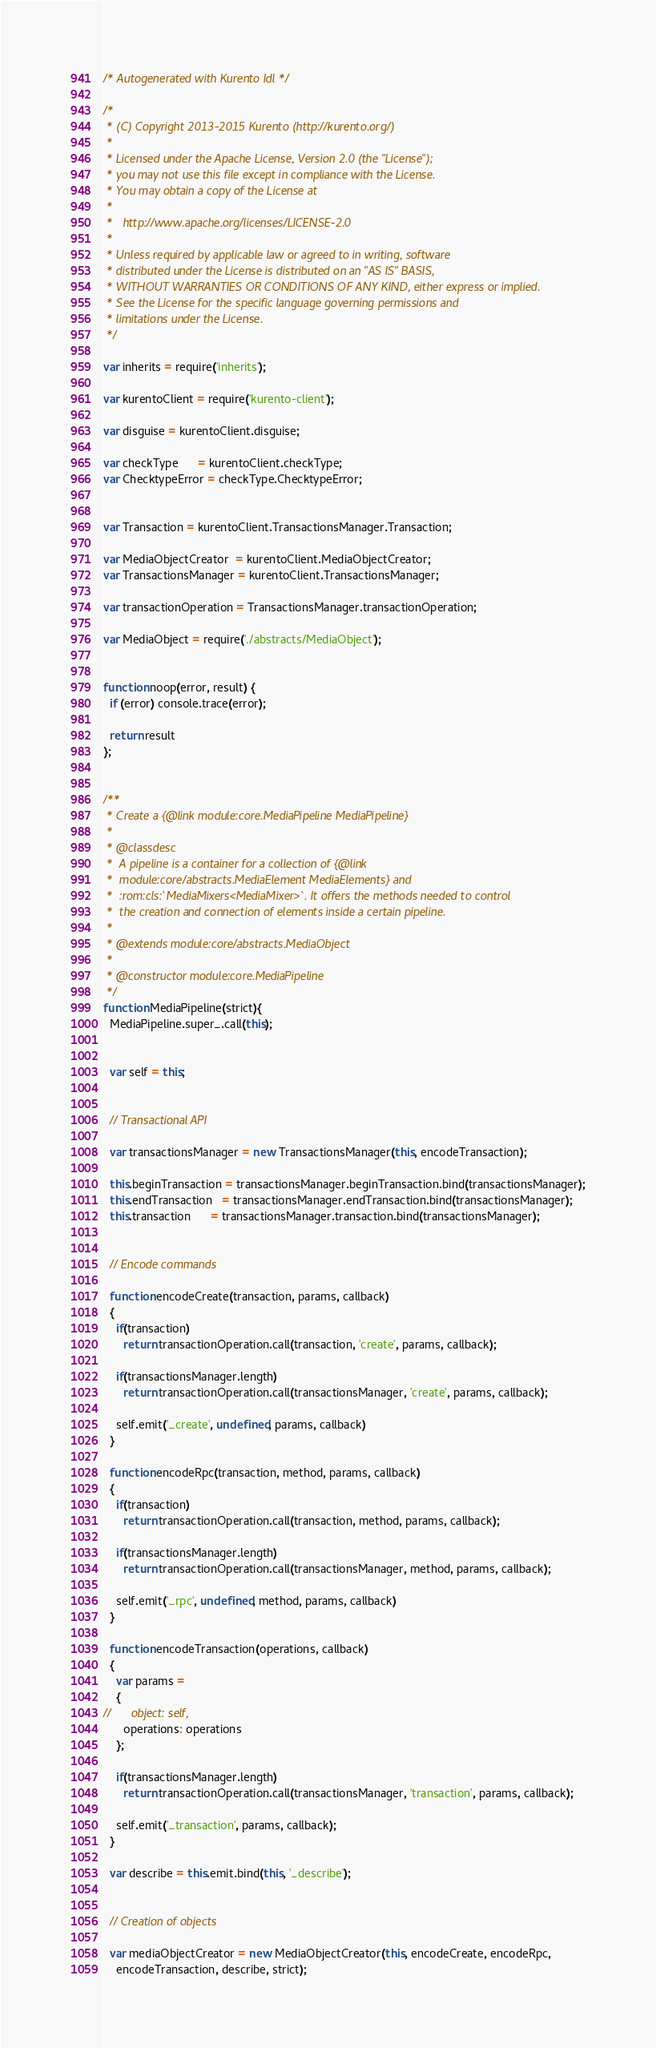<code> <loc_0><loc_0><loc_500><loc_500><_JavaScript_>/* Autogenerated with Kurento Idl */

/*
 * (C) Copyright 2013-2015 Kurento (http://kurento.org/)
 *
 * Licensed under the Apache License, Version 2.0 (the "License");
 * you may not use this file except in compliance with the License.
 * You may obtain a copy of the License at
 *
 *   http://www.apache.org/licenses/LICENSE-2.0
 *
 * Unless required by applicable law or agreed to in writing, software
 * distributed under the License is distributed on an "AS IS" BASIS,
 * WITHOUT WARRANTIES OR CONDITIONS OF ANY KIND, either express or implied.
 * See the License for the specific language governing permissions and
 * limitations under the License.
 */

var inherits = require('inherits');

var kurentoClient = require('kurento-client');

var disguise = kurentoClient.disguise;

var checkType      = kurentoClient.checkType;
var ChecktypeError = checkType.ChecktypeError;


var Transaction = kurentoClient.TransactionsManager.Transaction;

var MediaObjectCreator  = kurentoClient.MediaObjectCreator;
var TransactionsManager = kurentoClient.TransactionsManager;

var transactionOperation = TransactionsManager.transactionOperation;

var MediaObject = require('./abstracts/MediaObject');


function noop(error, result) {
  if (error) console.trace(error);

  return result
};


/**
 * Create a {@link module:core.MediaPipeline MediaPipeline}
 *
 * @classdesc
 *  A pipeline is a container for a collection of {@link 
 *  module:core/abstracts.MediaElement MediaElements} and 
 *  :rom:cls:`MediaMixers<MediaMixer>`. It offers the methods needed to control 
 *  the creation and connection of elements inside a certain pipeline.
 *
 * @extends module:core/abstracts.MediaObject
 *
 * @constructor module:core.MediaPipeline
 */
function MediaPipeline(strict){
  MediaPipeline.super_.call(this);


  var self = this;


  // Transactional API

  var transactionsManager = new TransactionsManager(this, encodeTransaction);

  this.beginTransaction = transactionsManager.beginTransaction.bind(transactionsManager);
  this.endTransaction   = transactionsManager.endTransaction.bind(transactionsManager);
  this.transaction      = transactionsManager.transaction.bind(transactionsManager);


  // Encode commands

  function encodeCreate(transaction, params, callback)
  {
    if(transaction)
      return transactionOperation.call(transaction, 'create', params, callback);

    if(transactionsManager.length)
      return transactionOperation.call(transactionsManager, 'create', params, callback);

    self.emit('_create', undefined, params, callback)
  }

  function encodeRpc(transaction, method, params, callback)
  {
    if(transaction)
      return transactionOperation.call(transaction, method, params, callback);

    if(transactionsManager.length)
      return transactionOperation.call(transactionsManager, method, params, callback);

    self.emit('_rpc', undefined, method, params, callback)
  }

  function encodeTransaction(operations, callback)
  {
    var params =
    {
//      object: self,
      operations: operations
    };

    if(transactionsManager.length)
      return transactionOperation.call(transactionsManager, 'transaction', params, callback);

    self.emit('_transaction', params, callback);
  }

  var describe = this.emit.bind(this, '_describe');


  // Creation of objects

  var mediaObjectCreator = new MediaObjectCreator(this, encodeCreate, encodeRpc,
    encodeTransaction, describe, strict);</code> 